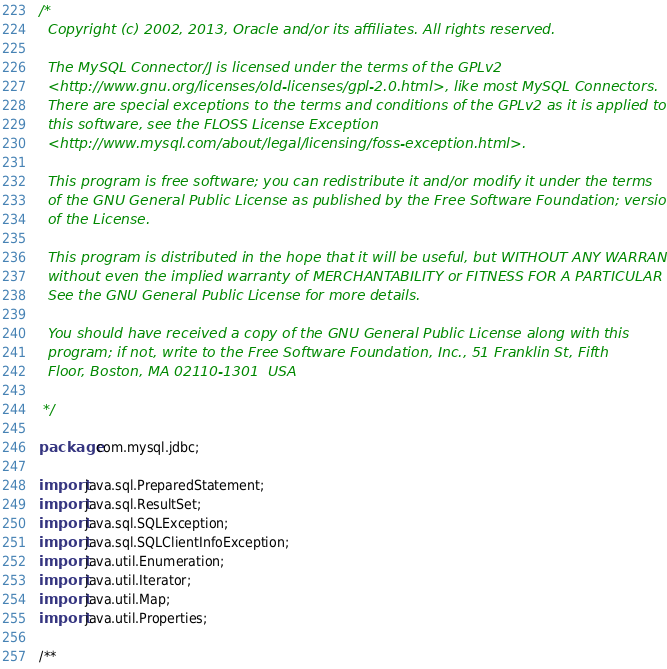<code> <loc_0><loc_0><loc_500><loc_500><_Java_>/*
  Copyright (c) 2002, 2013, Oracle and/or its affiliates. All rights reserved.

  The MySQL Connector/J is licensed under the terms of the GPLv2
  <http://www.gnu.org/licenses/old-licenses/gpl-2.0.html>, like most MySQL Connectors.
  There are special exceptions to the terms and conditions of the GPLv2 as it is applied to
  this software, see the FLOSS License Exception
  <http://www.mysql.com/about/legal/licensing/foss-exception.html>.

  This program is free software; you can redistribute it and/or modify it under the terms
  of the GNU General Public License as published by the Free Software Foundation; version 2
  of the License.

  This program is distributed in the hope that it will be useful, but WITHOUT ANY WARRANTY;
  without even the implied warranty of MERCHANTABILITY or FITNESS FOR A PARTICULAR PURPOSE.
  See the GNU General Public License for more details.

  You should have received a copy of the GNU General Public License along with this
  program; if not, write to the Free Software Foundation, Inc., 51 Franklin St, Fifth
  Floor, Boston, MA 02110-1301  USA

 */

package com.mysql.jdbc;

import java.sql.PreparedStatement;
import java.sql.ResultSet;
import java.sql.SQLException;
import java.sql.SQLClientInfoException;
import java.util.Enumeration;
import java.util.Iterator;
import java.util.Map;
import java.util.Properties;

/**</code> 